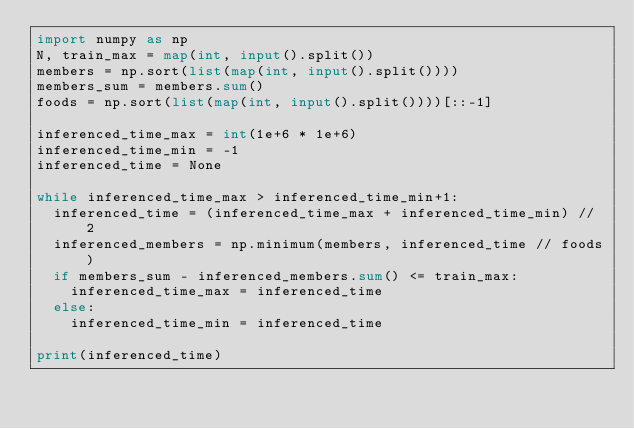Convert code to text. <code><loc_0><loc_0><loc_500><loc_500><_Python_>import numpy as np
N, train_max = map(int, input().split())
members = np.sort(list(map(int, input().split())))
members_sum = members.sum()
foods = np.sort(list(map(int, input().split())))[::-1]

inferenced_time_max = int(1e+6 * 1e+6)
inferenced_time_min = -1
inferenced_time = None

while inferenced_time_max > inferenced_time_min+1:
  inferenced_time = (inferenced_time_max + inferenced_time_min) // 2
  inferenced_members = np.minimum(members, inferenced_time // foods)
  if members_sum - inferenced_members.sum() <= train_max:
    inferenced_time_max = inferenced_time
  else:
    inferenced_time_min = inferenced_time

print(inferenced_time)</code> 